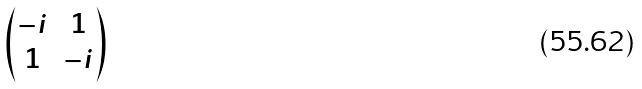<formula> <loc_0><loc_0><loc_500><loc_500>\begin{pmatrix} - i & 1 \\ 1 & - i \end{pmatrix}</formula> 